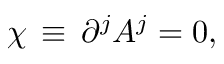<formula> <loc_0><loc_0><loc_500><loc_500>\chi \, \equiv \, \partial ^ { j } A ^ { j } = 0 ,</formula> 